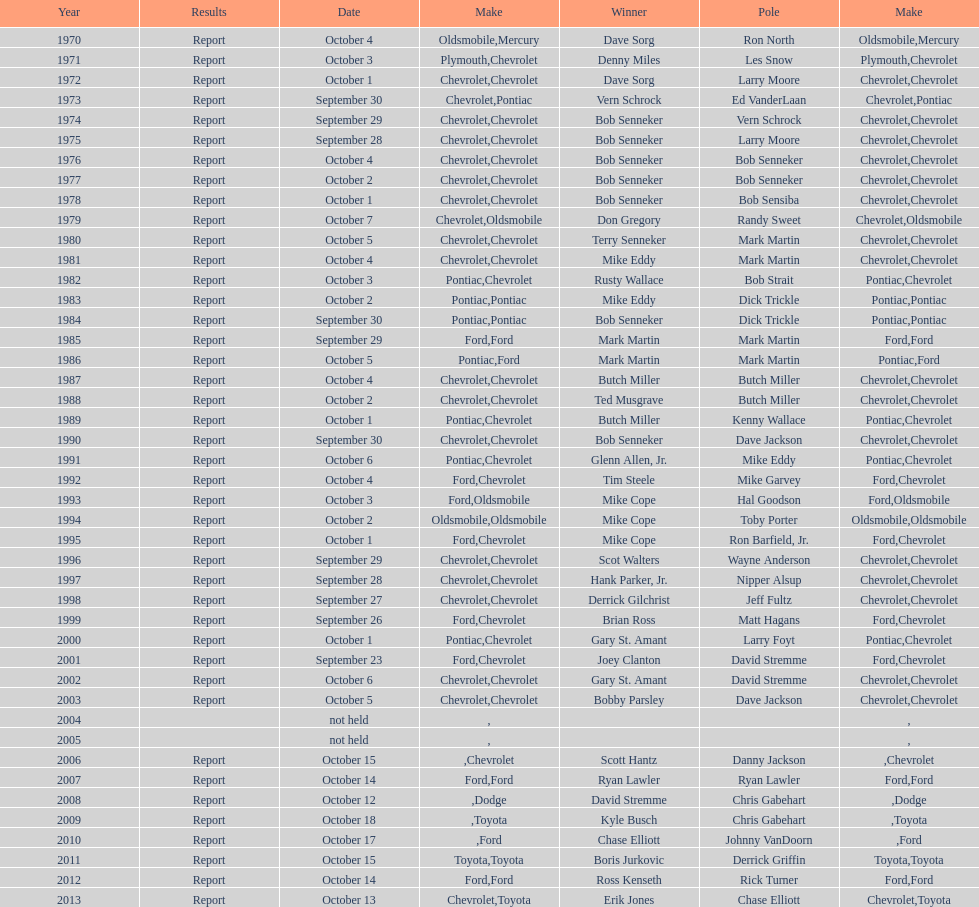Who on the list has the highest number of consecutive wins? Bob Senneker. 